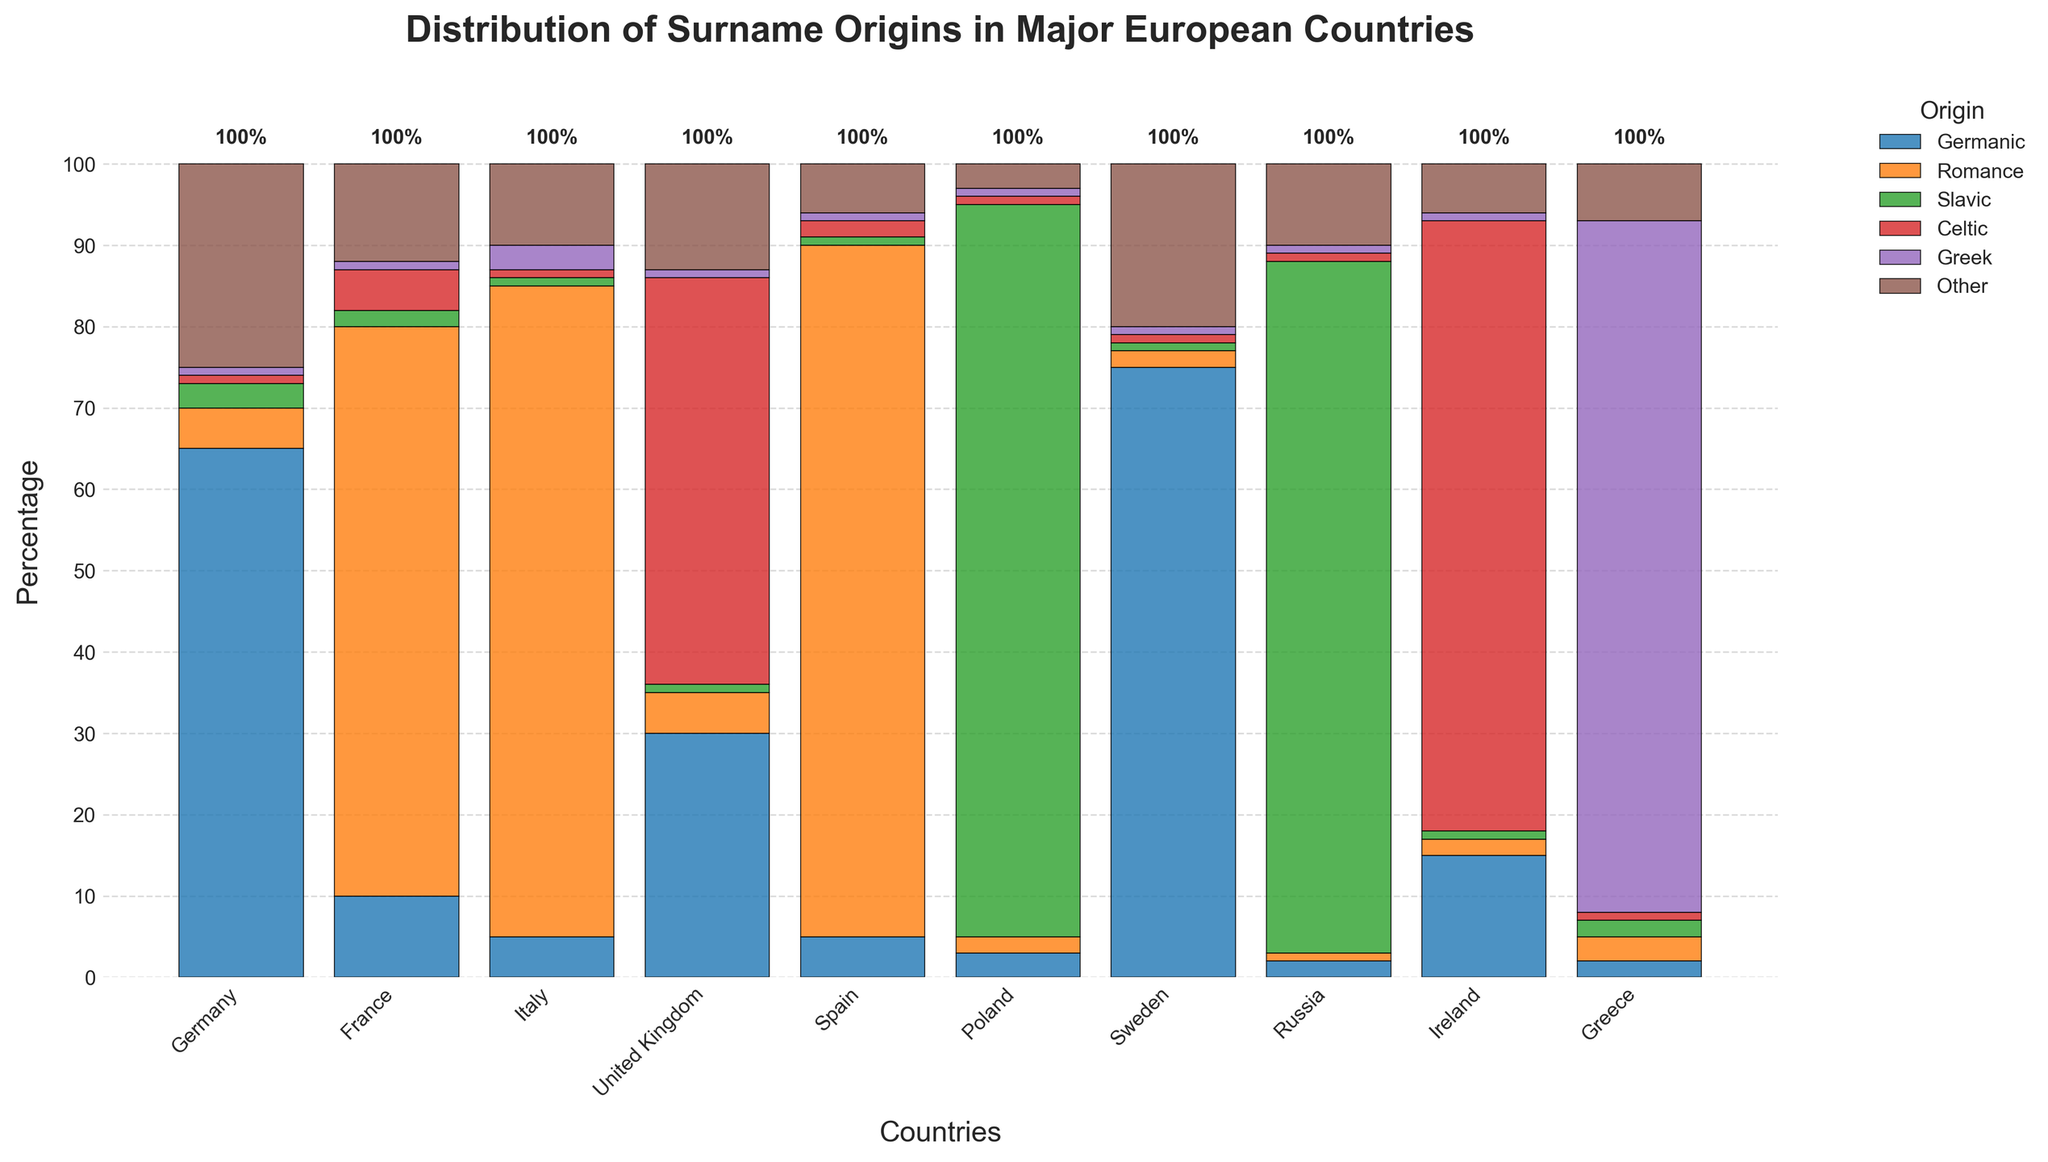Which country has the highest percentage of surnames with Germanic origin? Germany has the highest bar in the Germanic category, indicated by a tall bar with the percentage mentioned.
Answer: Germany How does the percentage of Romance origin surnames in Italy compare to that in France? The bar for Romance origin in Italy reaches 80%, while in France, it reaches 70%; therefore, Italy's percentage is higher.
Answer: Italy has a higher percentage Which country has the smallest percentage of surnames with Slavic origin? Countries like Germany, France, Italy, Spain, Sweden, United Kingdom, Greece, and Ireland show low bars for Slavic origin, all around or below 3%, but Germany (3%) and France (2%) collectively show the smallest percentage together.
Answer: France In which countries does the percentage of surnames from Celtic origins exceed 70%? The bars for Celtic origin in the United Kingdom and Ireland exceed the 70% mark, indicating that both countries have high percentages of Celtic surname origins.
Answer: The United Kingdom and Ireland Compare the total percentages of Germanic origin surnames in Sweden and Greece. By looking at the height of the bars, Sweden has a 75% Germanic origin while Greece shows only 2%; thus, Sweden has a significantly higher percentage.
Answer: Sweden Rank the countries in descending order of percentage of surnames of Greek origin. Bars for surnames of Greek origin are tallest in Greece (85%), followed by Italy (3%), France (1%), Spain (1%), Germany (1%), UK (1%), Poland (1%), Sweden (1%), Russia (1%), and Ireland (1%).
Answer: Greece, Italy, France, Spain, Germany, UK, Poland, Sweden, Russia, Ireland Sum the percentages of Germanic, Romance, and Slavic origins in France. Germanic (10%) + Romance (70%) + Slavic (2%) = 82%.
Answer: 82% Which country has the most diverse surname origins based on the 'Other' category's highest percentage? Germany shows the highest 'Other' category with a percentage of 25%, indicating the most diversity in this respect.
Answer: Germany Are there any countries where the sum of Romance and Slavic origins is less than 10%? Germany: Romance (5%) + Slavic (3%) = 8%, Sweden: Romance (2%) + Slavic (1%) = 3%, Russia: Romance (1%) + Slavic (85%) = 86%, Ireland: Romance (2%) + Slavic (1%) = 3%.
Answer: Germany, Sweden, Ireland How does the origin diversity (i.e., sum of lower percentile categories) in Russia compare to Sweden? In Russia, categories with low percentages are Germanic (2%), Romance (1%), Celtic (1%), Greek (1%), and Other (10%) sum to 15%. In Sweden, Germanic (75%), Romance (2%), Slavic (1%), Celtic (1%), Greek (1%), and Other (20%) sum to 100%. Russia has lower diversity in origin categories since fewer categories have low percentages.
Answer: Russia has less diversity 